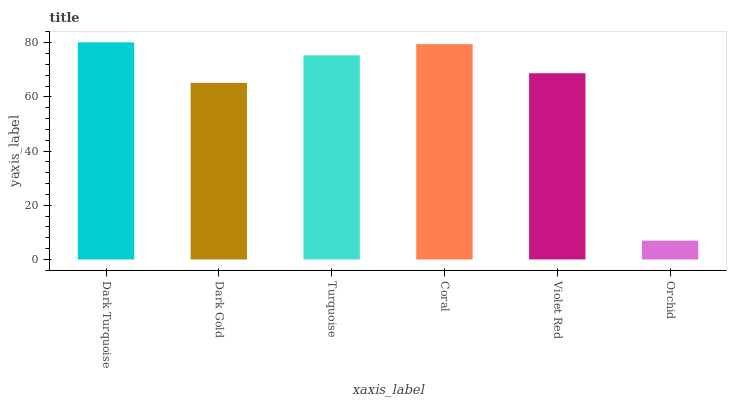Is Orchid the minimum?
Answer yes or no. Yes. Is Dark Turquoise the maximum?
Answer yes or no. Yes. Is Dark Gold the minimum?
Answer yes or no. No. Is Dark Gold the maximum?
Answer yes or no. No. Is Dark Turquoise greater than Dark Gold?
Answer yes or no. Yes. Is Dark Gold less than Dark Turquoise?
Answer yes or no. Yes. Is Dark Gold greater than Dark Turquoise?
Answer yes or no. No. Is Dark Turquoise less than Dark Gold?
Answer yes or no. No. Is Turquoise the high median?
Answer yes or no. Yes. Is Violet Red the low median?
Answer yes or no. Yes. Is Dark Turquoise the high median?
Answer yes or no. No. Is Coral the low median?
Answer yes or no. No. 